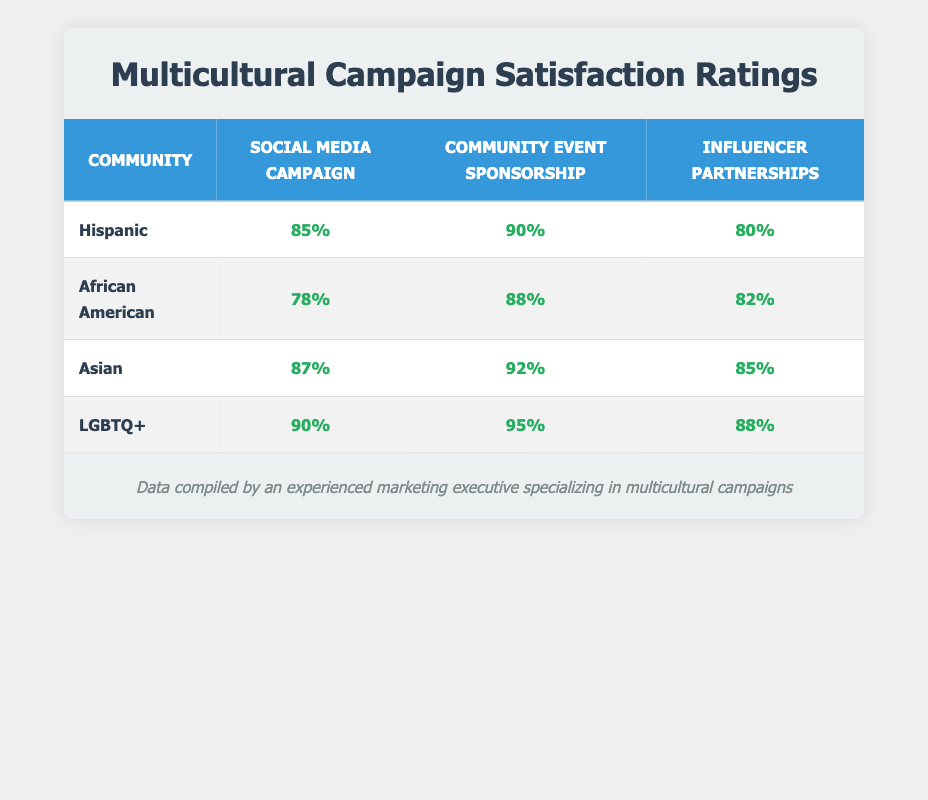What is the highest customer satisfaction rating among the promotional strategies for the LGBTQ+ community? The table shows that the highest customer satisfaction rating for the LGBTQ+ community is from Community Event Sponsorship with 95%.
Answer: 95% What is the customer satisfaction rating for Influencer Partnerships in the Hispanic community? The specific rating for Influencer Partnerships under the Hispanic community is listed in the table as 80%.
Answer: 80% Which promotional strategy yields the lowest customer satisfaction rating among the African American community? Looking at the ratings for the African American community, the Social Media Campaign has the lowest rating at 78%.
Answer: 78% What is the average customer satisfaction rating for the Community Event Sponsorship across all communities? The ratings for Community Event Sponsorship are 90 (Hispanic), 88 (African American), 92 (Asian), and 95 (LGBTQ+). Adding these ratings gives 90 + 88 + 92 + 95 = 365. Dividing by the number of communities (4) yields an average of 365/4 = 91.25.
Answer: 91.25 Is it true that the customer satisfaction rating for Social Media Campaigns in the Asian community is higher than in the Hispanic community? The ratings show that the Asian community has a satisfaction rating of 87% for Social Media Campaigns, while the Hispanic community has 85%. Therefore, the statement is true.
Answer: Yes What percentage difference is there in customer satisfaction ratings between the Community Event Sponsorship for the LGBTQ+ and African American communities? The Community Event Sponsorship rating for LGBTQ+ is 95% and for African American is 88%. The difference is 95 - 88 = 7%.
Answer: 7% Which community has the most effective promotional strategy based on the highest single customer satisfaction rating? Upon reviewing the ratings, the LGBTQ+ community's Community Event Sponsorship at 95% is the highest single rating in the table, indicating it is the most effective strategy.
Answer: LGBTQ+ community How does the customer satisfaction rating for Influencer Partnerships in the Asian community compare to that of Community Event Sponsorship in the Hispanic community? The table shows that Influencer Partnerships for the Asian community have a satisfaction rating of 85%, while Community Event Sponsorship for the Hispanic community shows a higher rating of 90%. Thus, Influencer Partnerships rate lower.
Answer: Lower 